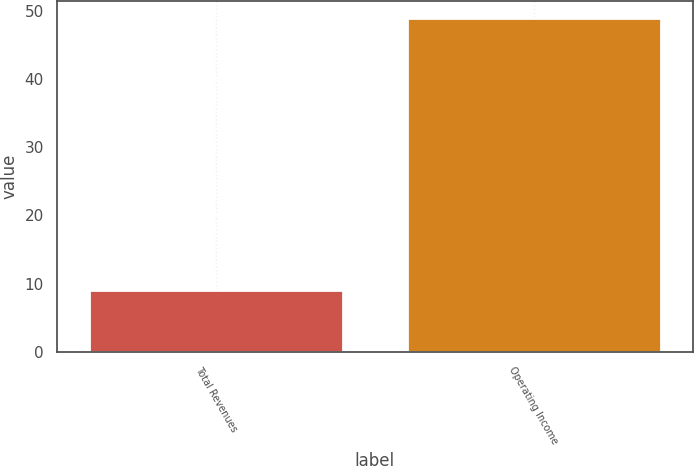Convert chart to OTSL. <chart><loc_0><loc_0><loc_500><loc_500><bar_chart><fcel>Total Revenues<fcel>Operating Income<nl><fcel>9<fcel>49<nl></chart> 